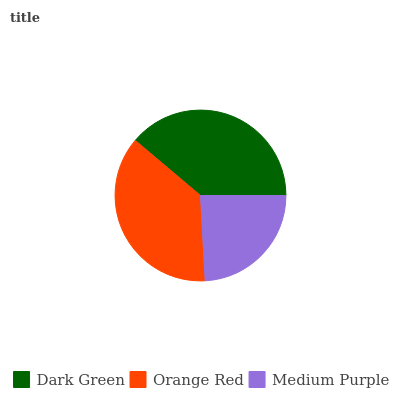Is Medium Purple the minimum?
Answer yes or no. Yes. Is Dark Green the maximum?
Answer yes or no. Yes. Is Orange Red the minimum?
Answer yes or no. No. Is Orange Red the maximum?
Answer yes or no. No. Is Dark Green greater than Orange Red?
Answer yes or no. Yes. Is Orange Red less than Dark Green?
Answer yes or no. Yes. Is Orange Red greater than Dark Green?
Answer yes or no. No. Is Dark Green less than Orange Red?
Answer yes or no. No. Is Orange Red the high median?
Answer yes or no. Yes. Is Orange Red the low median?
Answer yes or no. Yes. Is Dark Green the high median?
Answer yes or no. No. Is Medium Purple the low median?
Answer yes or no. No. 